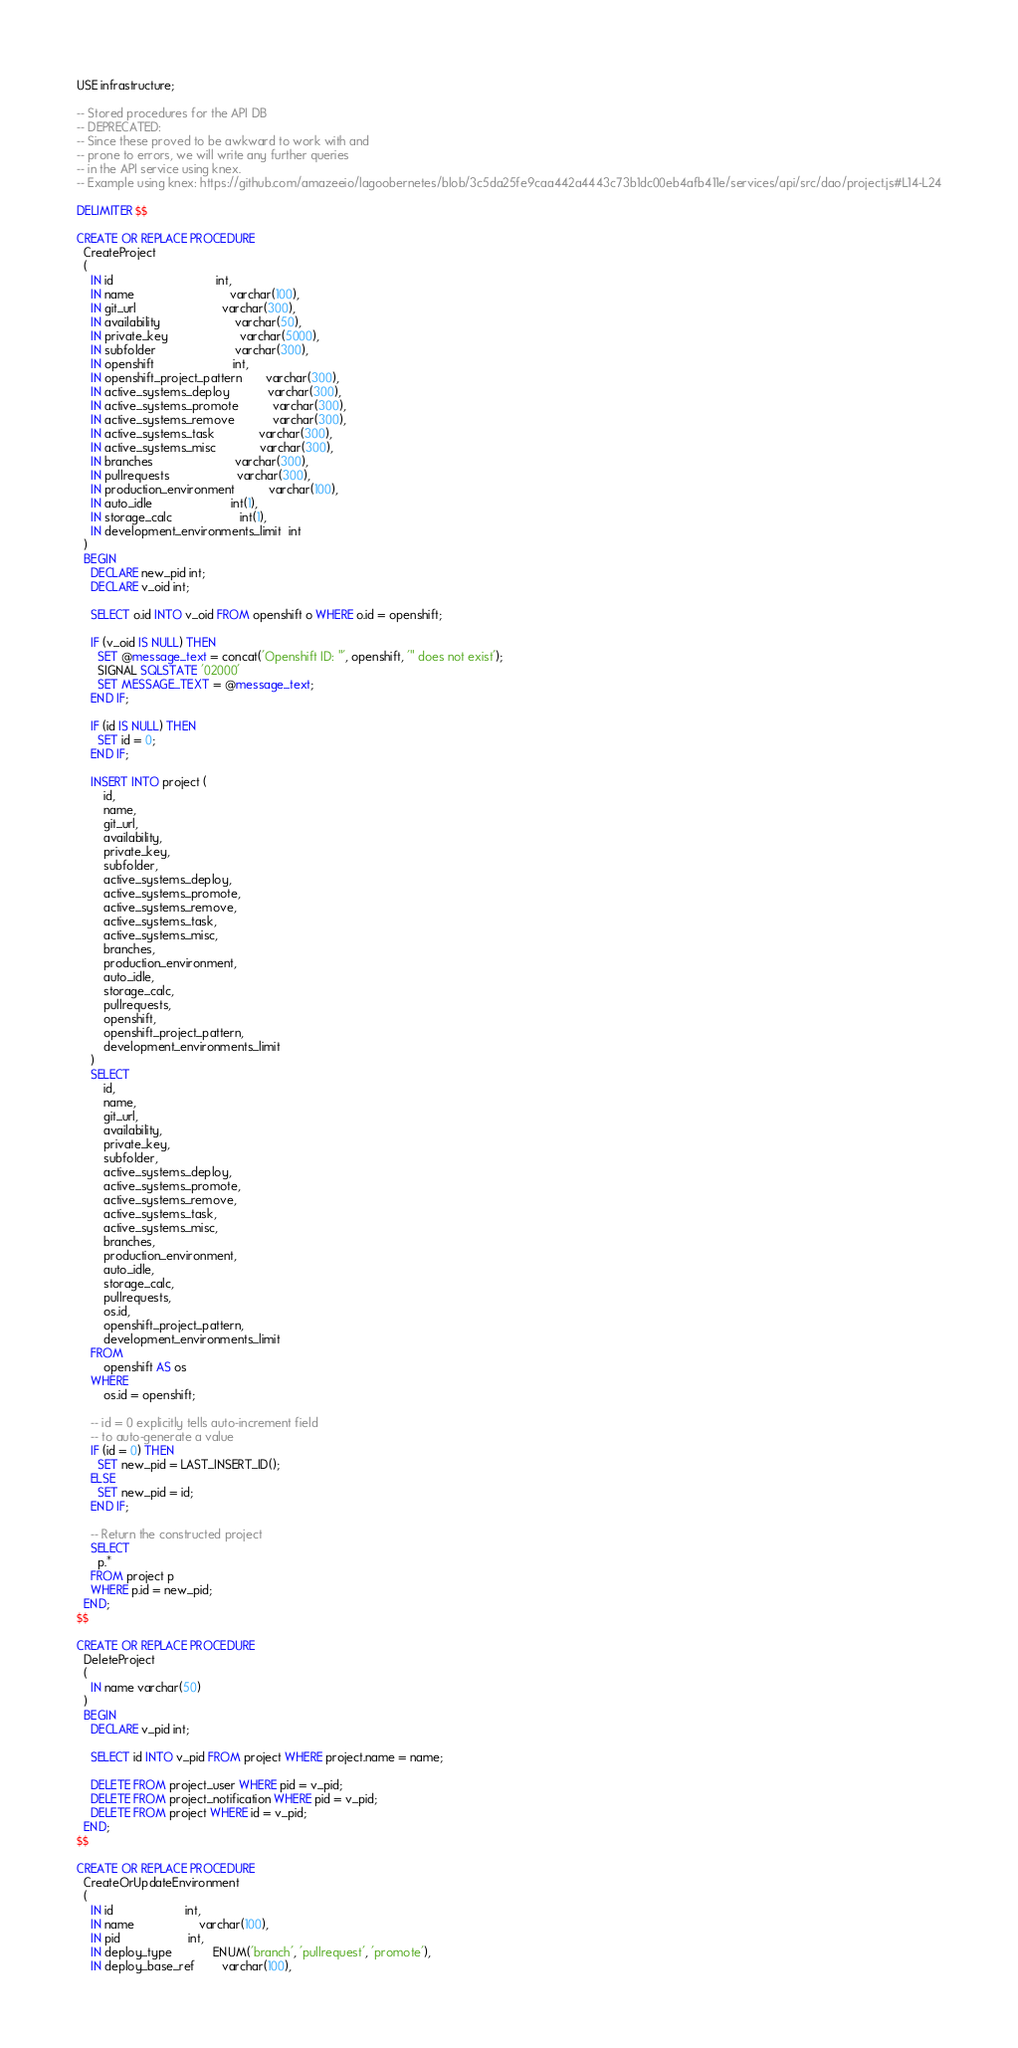Convert code to text. <code><loc_0><loc_0><loc_500><loc_500><_SQL_>USE infrastructure;

-- Stored procedures for the API DB
-- DEPRECATED:
-- Since these proved to be awkward to work with and
-- prone to errors, we will write any further queries
-- in the API service using knex.
-- Example using knex: https://github.com/amazeeio/lagoobernetes/blob/3c5da25fe9caa442a4443c73b1dc00eb4afb411e/services/api/src/dao/project.js#L14-L24

DELIMITER $$

CREATE OR REPLACE PROCEDURE
  CreateProject
  (
    IN id                              int,
    IN name                            varchar(100),
    IN git_url                         varchar(300),
    IN availability                      varchar(50),
    IN private_key                     varchar(5000),
    IN subfolder                       varchar(300),
    IN openshift                       int,
    IN openshift_project_pattern       varchar(300),
    IN active_systems_deploy           varchar(300),
    IN active_systems_promote          varchar(300),
    IN active_systems_remove           varchar(300),
    IN active_systems_task             varchar(300),
    IN active_systems_misc             varchar(300),
    IN branches                        varchar(300),
    IN pullrequests                    varchar(300),
    IN production_environment          varchar(100),
    IN auto_idle                       int(1),
    IN storage_calc                    int(1),
    IN development_environments_limit  int
  )
  BEGIN
    DECLARE new_pid int;
    DECLARE v_oid int;

    SELECT o.id INTO v_oid FROM openshift o WHERE o.id = openshift;

    IF (v_oid IS NULL) THEN
      SET @message_text = concat('Openshift ID: "', openshift, '" does not exist');
      SIGNAL SQLSTATE '02000'
      SET MESSAGE_TEXT = @message_text;
    END IF;

    IF (id IS NULL) THEN
      SET id = 0;
    END IF;

    INSERT INTO project (
        id,
        name,
        git_url,
        availability,
        private_key,
        subfolder,
        active_systems_deploy,
        active_systems_promote,
        active_systems_remove,
        active_systems_task,
        active_systems_misc,
        branches,
        production_environment,
        auto_idle,
        storage_calc,
        pullrequests,
        openshift,
        openshift_project_pattern,
        development_environments_limit
    )
    SELECT
        id,
        name,
        git_url,
        availability,
        private_key,
        subfolder,
        active_systems_deploy,
        active_systems_promote,
        active_systems_remove,
        active_systems_task,
        active_systems_misc,
        branches,
        production_environment,
        auto_idle,
        storage_calc,
        pullrequests,
        os.id,
        openshift_project_pattern,
        development_environments_limit
    FROM
        openshift AS os
    WHERE
        os.id = openshift;

    -- id = 0 explicitly tells auto-increment field
    -- to auto-generate a value
    IF (id = 0) THEN
      SET new_pid = LAST_INSERT_ID();
    ELSE
      SET new_pid = id;
    END IF;

    -- Return the constructed project
    SELECT
      p.*
    FROM project p
    WHERE p.id = new_pid;
  END;
$$

CREATE OR REPLACE PROCEDURE
  DeleteProject
  (
    IN name varchar(50)
  )
  BEGIN
    DECLARE v_pid int;

    SELECT id INTO v_pid FROM project WHERE project.name = name;

    DELETE FROM project_user WHERE pid = v_pid;
    DELETE FROM project_notification WHERE pid = v_pid;
    DELETE FROM project WHERE id = v_pid;
  END;
$$

CREATE OR REPLACE PROCEDURE
  CreateOrUpdateEnvironment
  (
    IN id                     int,
    IN name                   varchar(100),
    IN pid                    int,
    IN deploy_type            ENUM('branch', 'pullrequest', 'promote'),
    IN deploy_base_ref        varchar(100),</code> 